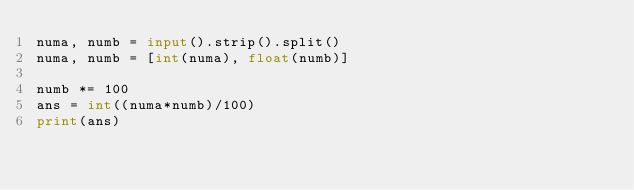<code> <loc_0><loc_0><loc_500><loc_500><_Python_>numa, numb = input().strip().split()
numa, numb = [int(numa), float(numb)]

numb *= 100
ans = int((numa*numb)/100)
print(ans)</code> 